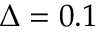<formula> <loc_0><loc_0><loc_500><loc_500>\Delta = 0 . 1</formula> 